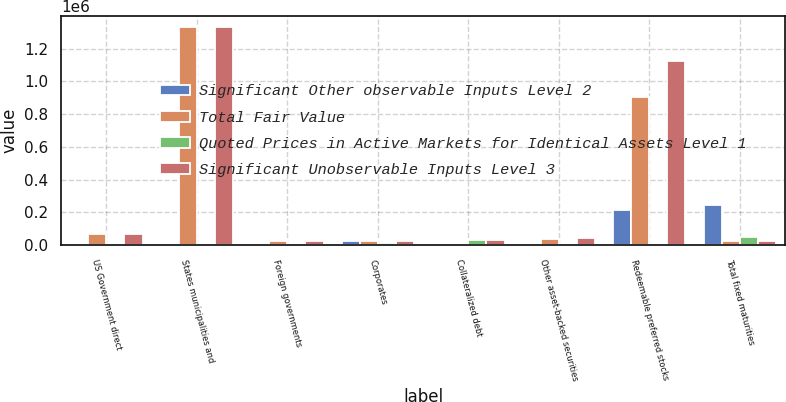Convert chart to OTSL. <chart><loc_0><loc_0><loc_500><loc_500><stacked_bar_chart><ecel><fcel>US Government direct<fcel>States municipalities and<fcel>Foreign governments<fcel>Corporates<fcel>Collateralized debt<fcel>Other asset-backed securities<fcel>Redeemable preferred stocks<fcel>Total fixed maturities<nl><fcel>Significant Other observable Inputs Level 2<fcel>0<fcel>0<fcel>0<fcel>28092<fcel>0<fcel>0<fcel>217613<fcel>245705<nl><fcel>Total Fair Value<fcel>67035<fcel>1.32982e+06<fcel>23159<fcel>25625.5<fcel>0<fcel>37558<fcel>904656<fcel>25625.5<nl><fcel>Quoted Prices in Active Markets for Identical Assets Level 1<fcel>0<fcel>0<fcel>0<fcel>11250<fcel>30320<fcel>7122<fcel>0<fcel>48692<nl><fcel>Significant Unobservable Inputs Level 3<fcel>67035<fcel>1.32982e+06<fcel>23159<fcel>25625.5<fcel>30320<fcel>44680<fcel>1.12227e+06<fcel>25625.5<nl></chart> 